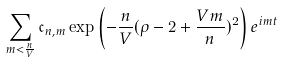Convert formula to latex. <formula><loc_0><loc_0><loc_500><loc_500>\sum _ { m < \frac { n } { V } } \mathfrak { c } _ { n , m } \exp \left ( - \frac { n } { V } ( \rho - 2 + \frac { V m } { n } ) ^ { 2 } \right ) e ^ { i m t }</formula> 